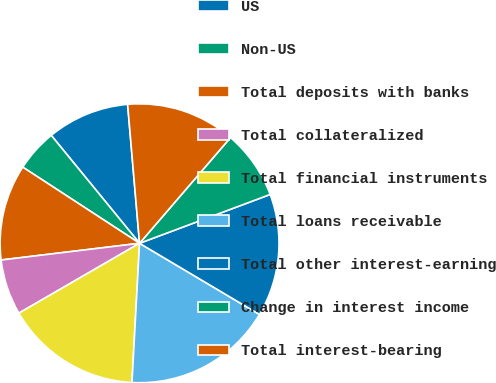Convert chart. <chart><loc_0><loc_0><loc_500><loc_500><pie_chart><fcel>US<fcel>Non-US<fcel>Total deposits with banks<fcel>Total collateralized<fcel>Total financial instruments<fcel>Total loans receivable<fcel>Total other interest-earning<fcel>Change in interest income<fcel>Total interest-bearing<nl><fcel>9.55%<fcel>4.89%<fcel>11.11%<fcel>6.44%<fcel>15.78%<fcel>17.34%<fcel>14.22%<fcel>8.0%<fcel>12.67%<nl></chart> 